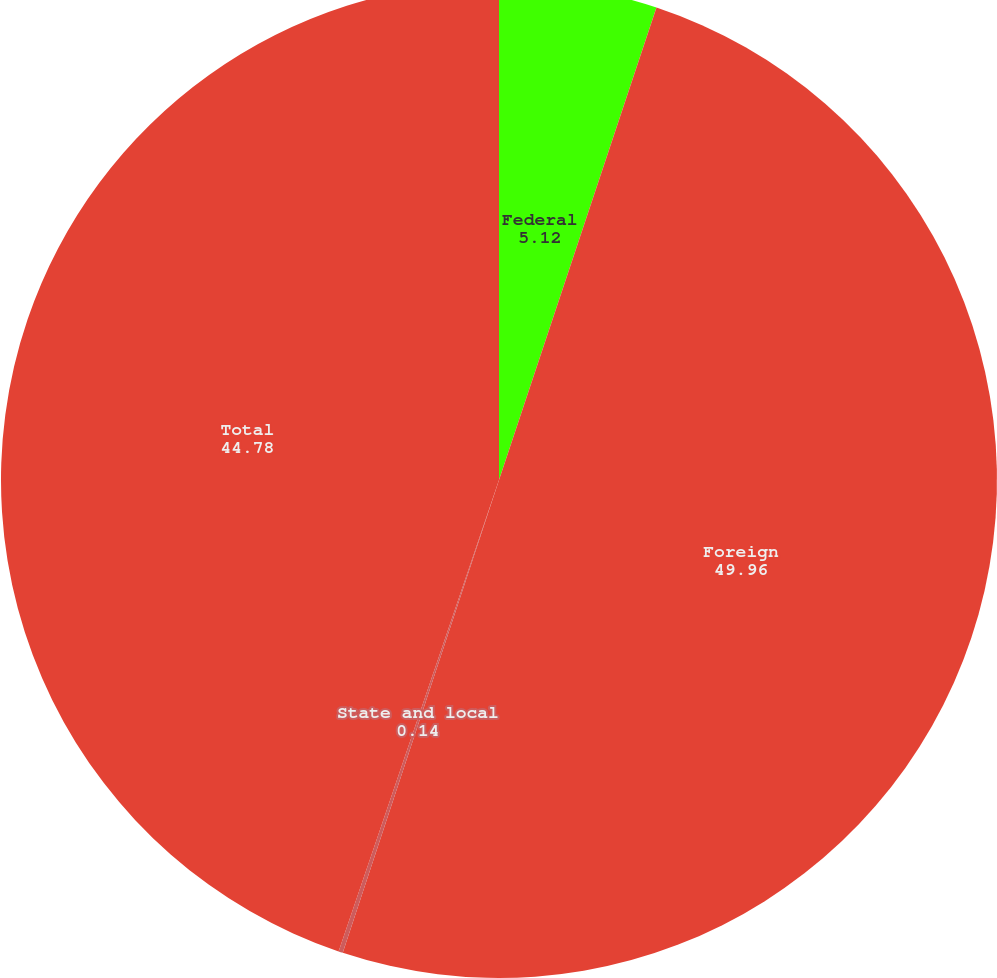Convert chart. <chart><loc_0><loc_0><loc_500><loc_500><pie_chart><fcel>Federal<fcel>Foreign<fcel>State and local<fcel>Total<nl><fcel>5.12%<fcel>49.96%<fcel>0.14%<fcel>44.78%<nl></chart> 